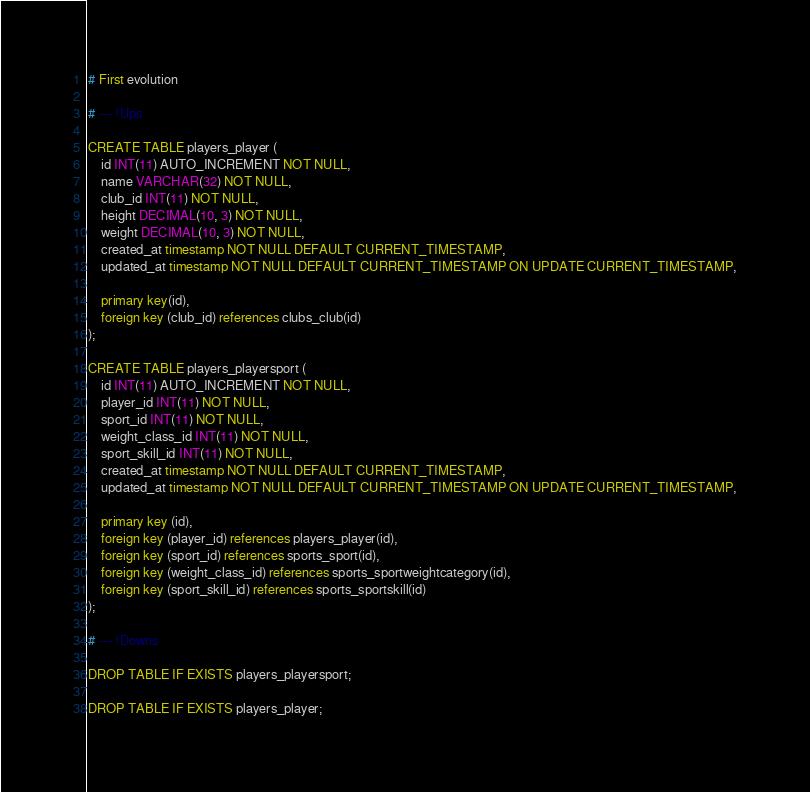<code> <loc_0><loc_0><loc_500><loc_500><_SQL_># First evolution

# --- !Ups

CREATE TABLE players_player (
    id INT(11) AUTO_INCREMENT NOT NULL,
    name VARCHAR(32) NOT NULL,
    club_id INT(11) NOT NULL,
    height DECIMAL(10, 3) NOT NULL,
    weight DECIMAL(10, 3) NOT NULL,
    created_at timestamp NOT NULL DEFAULT CURRENT_TIMESTAMP,
    updated_at timestamp NOT NULL DEFAULT CURRENT_TIMESTAMP ON UPDATE CURRENT_TIMESTAMP,

    primary key(id),
    foreign key (club_id) references clubs_club(id)
);

CREATE TABLE players_playersport (
    id INT(11) AUTO_INCREMENT NOT NULL,
    player_id INT(11) NOT NULL,
    sport_id INT(11) NOT NULL,
    weight_class_id INT(11) NOT NULL,
    sport_skill_id INT(11) NOT NULL,
    created_at timestamp NOT NULL DEFAULT CURRENT_TIMESTAMP,
    updated_at timestamp NOT NULL DEFAULT CURRENT_TIMESTAMP ON UPDATE CURRENT_TIMESTAMP,

    primary key (id),
    foreign key (player_id) references players_player(id),
    foreign key (sport_id) references sports_sport(id),
    foreign key (weight_class_id) references sports_sportweightcategory(id),
    foreign key (sport_skill_id) references sports_sportskill(id)
);

# --- !Downs

DROP TABLE IF EXISTS players_playersport;

DROP TABLE IF EXISTS players_player;</code> 